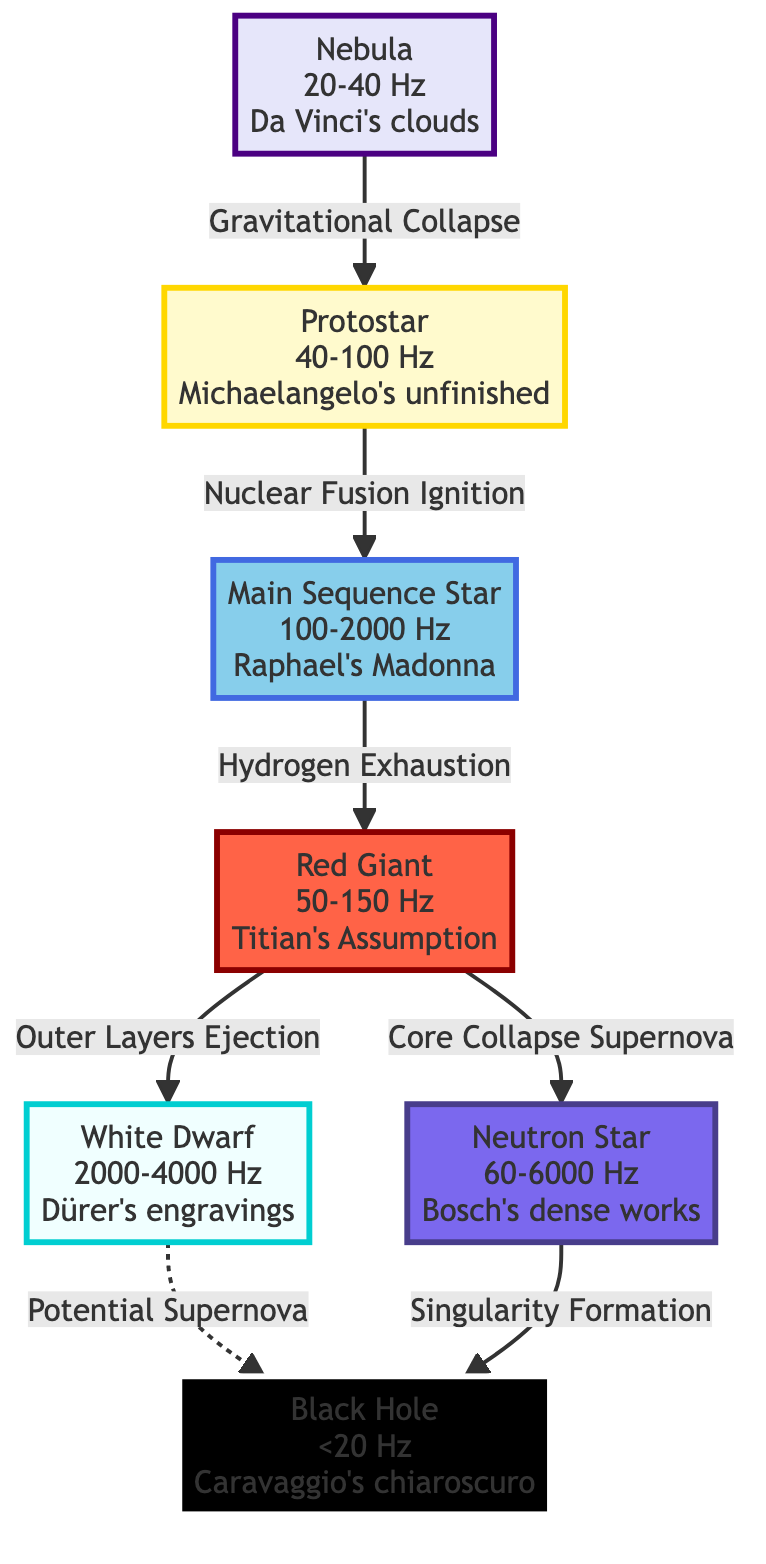What are the acoustic frequencies associated with a Nebula? The Nebula node in the diagram indicates an acoustic frequency range of 20-40 Hz.
Answer: 20-40 Hz Which visual art reference is associated with the white dwarf stage? According to the diagram, Dürer's engravings are associated with the white dwarf stage.
Answer: Dürer's engravings How many stages are there in stellar evolution depicted in this diagram? By counting the nodes in the diagram, there are a total of seven stages represented.
Answer: 7 What transformation occurs from a red giant to a neutron star? The flow should be followed from the red giant stage to the neutron star stage, where core collapse supernova occurs.
Answer: Core Collapse Supernova Which stellar evolution stage comes after a protostar? Following the protostar stage, according to the flow, the next stage is the main sequence star.
Answer: Main Sequence Star What is the frequency range for a neutron star? The neutron star stage is represented with an acoustic frequency range of 60-6000 Hz in the diagram.
Answer: 60-6000 Hz What happens to a white dwarf in terms of potential outcomes? The diagram indicates that a white dwarf can potentially lead to a black hole, shown by a dashed line labeled "Potential Supernova."
Answer: Potential Supernova What visual art reference corresponds with the main sequence star stage? The diagram associates Raphael's Madonna as the visual art reference for the main sequence star stage.
Answer: Raphael's Madonna 